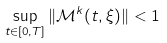<formula> <loc_0><loc_0><loc_500><loc_500>\sup _ { t \in [ 0 , T ] } \| \mathcal { M } ^ { k } ( t , \xi ) \| < 1</formula> 